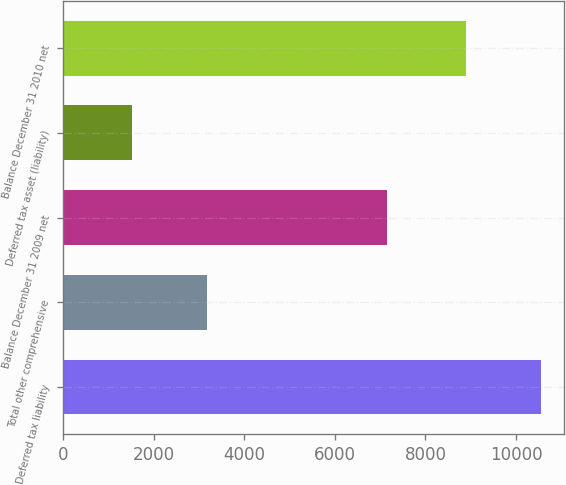<chart> <loc_0><loc_0><loc_500><loc_500><bar_chart><fcel>Deferred tax liability<fcel>Total other comprehensive<fcel>Balance December 31 2009 net<fcel>Deferred tax asset (liability)<fcel>Balance December 31 2010 net<nl><fcel>10544<fcel>3185<fcel>7145<fcel>1529<fcel>8888<nl></chart> 